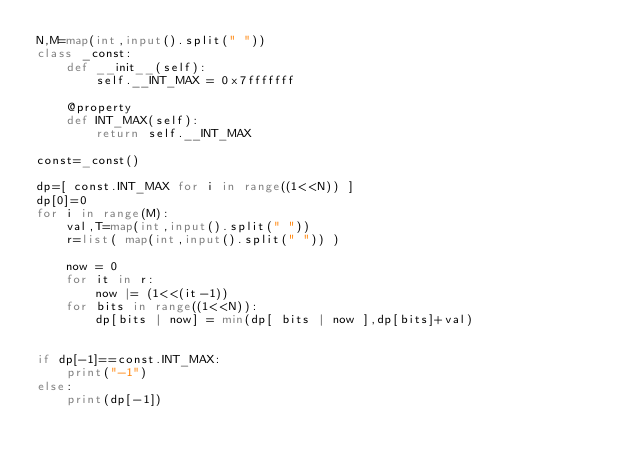Convert code to text. <code><loc_0><loc_0><loc_500><loc_500><_Python_>N,M=map(int,input().split(" "))
class _const:
    def __init__(self):
        self.__INT_MAX = 0x7fffffff

    @property
    def INT_MAX(self):
        return self.__INT_MAX

const=_const()

dp=[ const.INT_MAX for i in range((1<<N)) ]
dp[0]=0
for i in range(M):
    val,T=map(int,input().split(" "))
    r=list( map(int,input().split(" ")) )
    
    now = 0
    for it in r:
        now |= (1<<(it-1))
    for bits in range((1<<N)):
        dp[bits | now] = min(dp[ bits | now ],dp[bits]+val)


if dp[-1]==const.INT_MAX:
    print("-1")
else:
    print(dp[-1])


</code> 